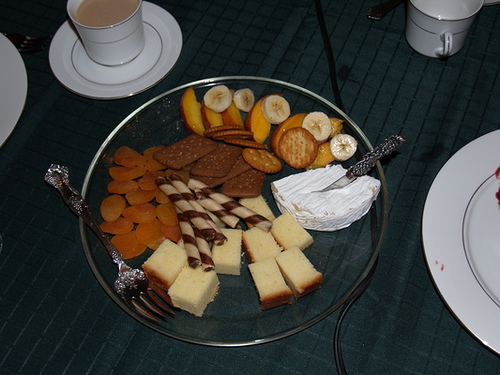<image>
Can you confirm if the cheese is next to the knife? No. The cheese is not positioned next to the knife. They are located in different areas of the scene. 